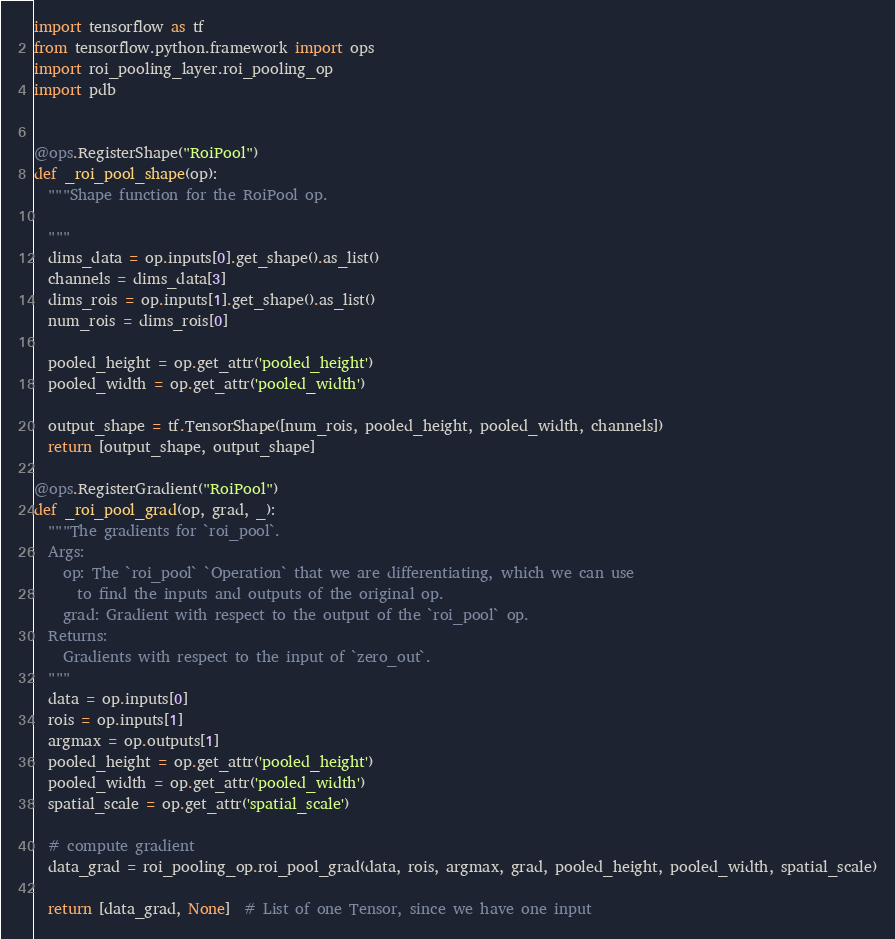Convert code to text. <code><loc_0><loc_0><loc_500><loc_500><_Python_>import tensorflow as tf
from tensorflow.python.framework import ops
import roi_pooling_layer.roi_pooling_op
import pdb


@ops.RegisterShape("RoiPool")
def _roi_pool_shape(op):
  """Shape function for the RoiPool op.

  """
  dims_data = op.inputs[0].get_shape().as_list()
  channels = dims_data[3]
  dims_rois = op.inputs[1].get_shape().as_list()
  num_rois = dims_rois[0]

  pooled_height = op.get_attr('pooled_height')
  pooled_width = op.get_attr('pooled_width')

  output_shape = tf.TensorShape([num_rois, pooled_height, pooled_width, channels])
  return [output_shape, output_shape]

@ops.RegisterGradient("RoiPool")
def _roi_pool_grad(op, grad, _):
  """The gradients for `roi_pool`.
  Args:
    op: The `roi_pool` `Operation` that we are differentiating, which we can use
      to find the inputs and outputs of the original op.
    grad: Gradient with respect to the output of the `roi_pool` op.
  Returns:
    Gradients with respect to the input of `zero_out`.
  """
  data = op.inputs[0]
  rois = op.inputs[1]
  argmax = op.outputs[1]
  pooled_height = op.get_attr('pooled_height')
  pooled_width = op.get_attr('pooled_width')
  spatial_scale = op.get_attr('spatial_scale')

  # compute gradient
  data_grad = roi_pooling_op.roi_pool_grad(data, rois, argmax, grad, pooled_height, pooled_width, spatial_scale)

  return [data_grad, None]  # List of one Tensor, since we have one input
</code> 